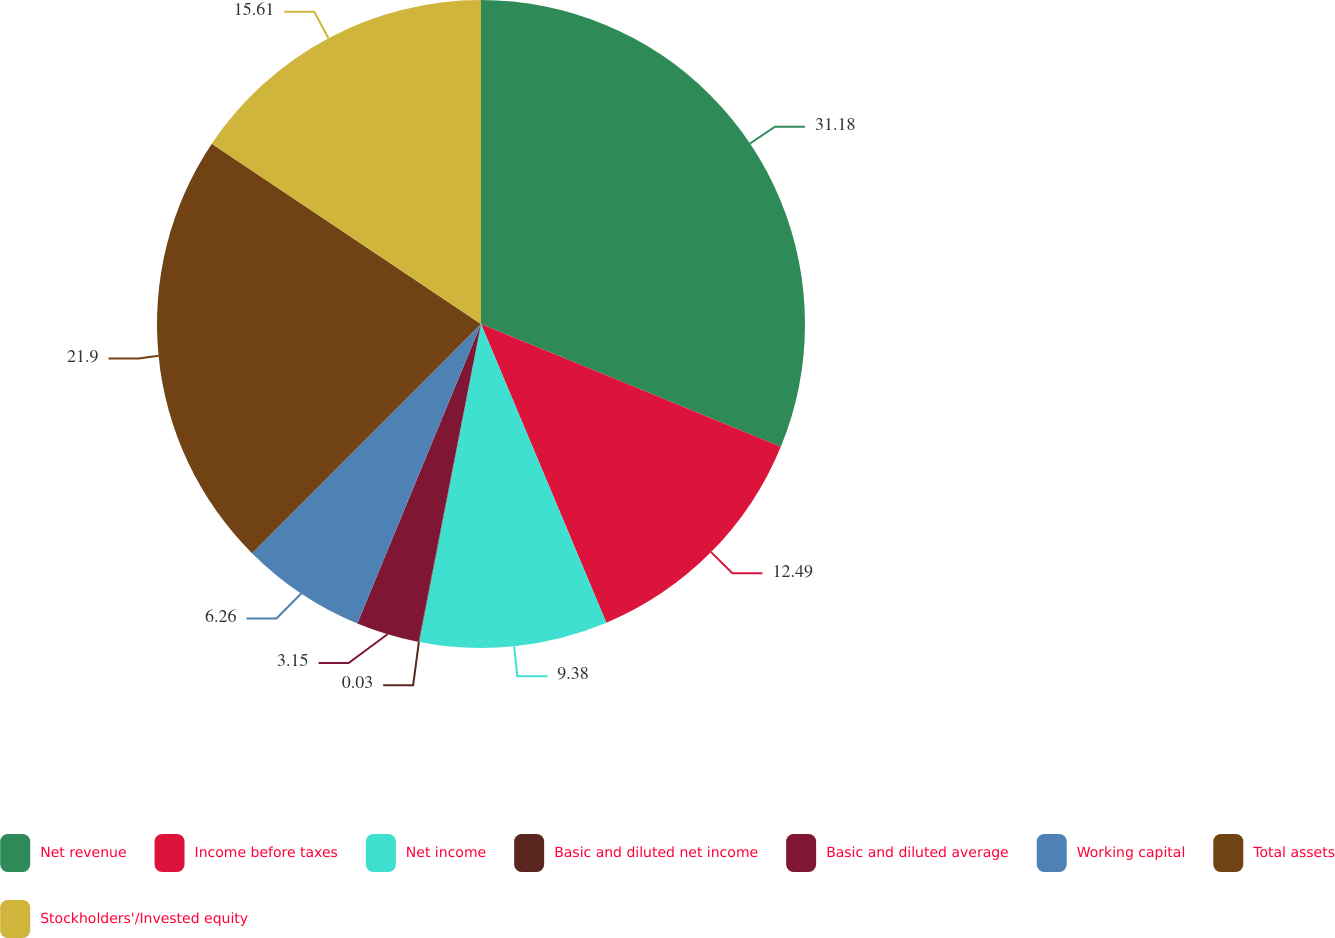Convert chart to OTSL. <chart><loc_0><loc_0><loc_500><loc_500><pie_chart><fcel>Net revenue<fcel>Income before taxes<fcel>Net income<fcel>Basic and diluted net income<fcel>Basic and diluted average<fcel>Working capital<fcel>Total assets<fcel>Stockholders'/Invested equity<nl><fcel>31.19%<fcel>12.49%<fcel>9.38%<fcel>0.03%<fcel>3.15%<fcel>6.26%<fcel>21.9%<fcel>15.61%<nl></chart> 